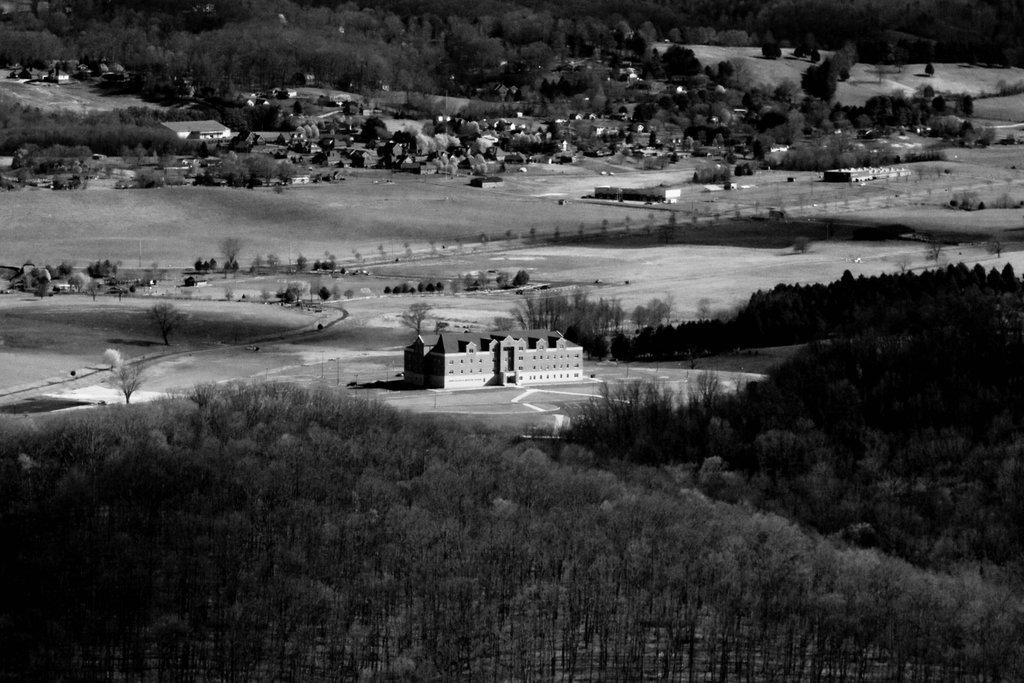What type of natural elements can be seen in the image? There are many trees in the image. What type of man-made structure is present in the image? There is a building in the image. What is visible at the bottom of the image? The ground is visible at the bottom of the image. What type of vegetation can be seen in the background of the image? There are plants in the background of the image. What type of pin can be seen holding the trees together in the image? There is no pin present in the image; the trees are not held together by any pin. What emotion is displayed by the passenger in the image? There is no passenger present in the image, so it is not possible to determine any emotion. 